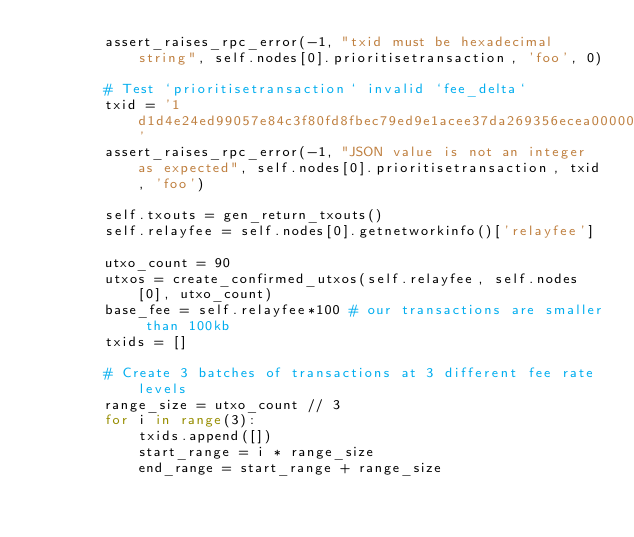<code> <loc_0><loc_0><loc_500><loc_500><_Python_>        assert_raises_rpc_error(-1, "txid must be hexadecimal string", self.nodes[0].prioritisetransaction, 'foo', 0)

        # Test `prioritisetransaction` invalid `fee_delta`
        txid = '1d1d4e24ed99057e84c3f80fd8fbec79ed9e1acee37da269356ecea000000000'
        assert_raises_rpc_error(-1, "JSON value is not an integer as expected", self.nodes[0].prioritisetransaction, txid, 'foo')

        self.txouts = gen_return_txouts()
        self.relayfee = self.nodes[0].getnetworkinfo()['relayfee']

        utxo_count = 90
        utxos = create_confirmed_utxos(self.relayfee, self.nodes[0], utxo_count)
        base_fee = self.relayfee*100 # our transactions are smaller than 100kb
        txids = []

        # Create 3 batches of transactions at 3 different fee rate levels
        range_size = utxo_count // 3
        for i in range(3):
            txids.append([])
            start_range = i * range_size
            end_range = start_range + range_size</code> 